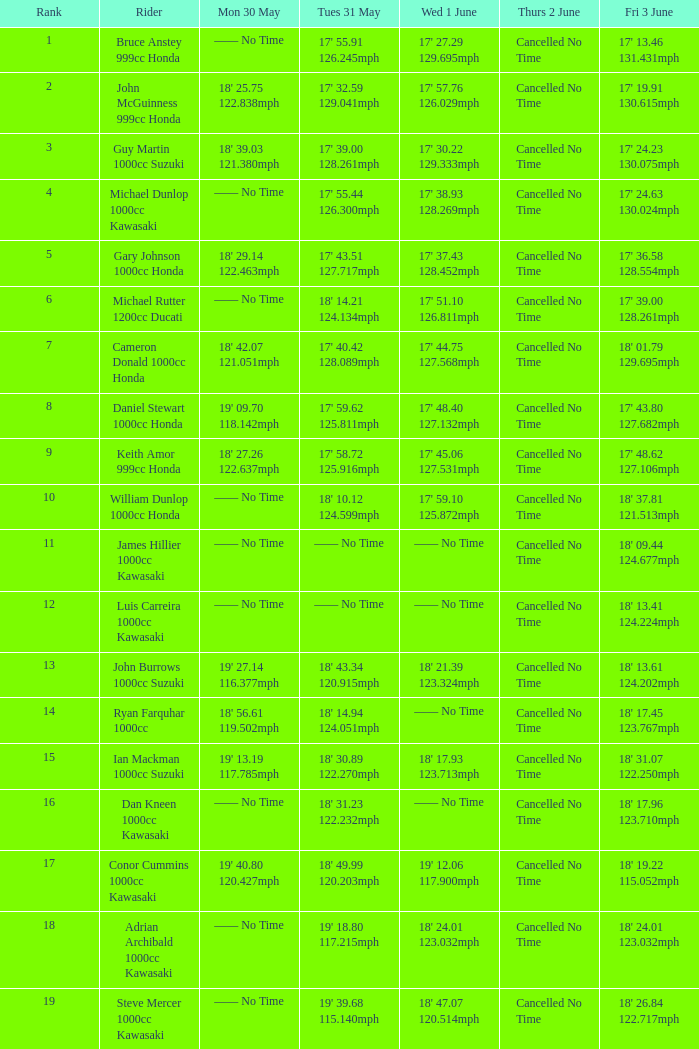Help me parse the entirety of this table. {'header': ['Rank', 'Rider', 'Mon 30 May', 'Tues 31 May', 'Wed 1 June', 'Thurs 2 June', 'Fri 3 June'], 'rows': [['1', 'Bruce Anstey 999cc Honda', '—— No Time', "17' 55.91 126.245mph", "17' 27.29 129.695mph", 'Cancelled No Time', "17' 13.46 131.431mph"], ['2', 'John McGuinness 999cc Honda', "18' 25.75 122.838mph", "17' 32.59 129.041mph", "17' 57.76 126.029mph", 'Cancelled No Time', "17' 19.91 130.615mph"], ['3', 'Guy Martin 1000cc Suzuki', "18' 39.03 121.380mph", "17' 39.00 128.261mph", "17' 30.22 129.333mph", 'Cancelled No Time', "17' 24.23 130.075mph"], ['4', 'Michael Dunlop 1000cc Kawasaki', '—— No Time', "17' 55.44 126.300mph", "17' 38.93 128.269mph", 'Cancelled No Time', "17' 24.63 130.024mph"], ['5', 'Gary Johnson 1000cc Honda', "18' 29.14 122.463mph", "17' 43.51 127.717mph", "17' 37.43 128.452mph", 'Cancelled No Time', "17' 36.58 128.554mph"], ['6', 'Michael Rutter 1200cc Ducati', '—— No Time', "18' 14.21 124.134mph", "17' 51.10 126.811mph", 'Cancelled No Time', "17' 39.00 128.261mph"], ['7', 'Cameron Donald 1000cc Honda', "18' 42.07 121.051mph", "17' 40.42 128.089mph", "17' 44.75 127.568mph", 'Cancelled No Time', "18' 01.79 129.695mph"], ['8', 'Daniel Stewart 1000cc Honda', "19' 09.70 118.142mph", "17' 59.62 125.811mph", "17' 48.40 127.132mph", 'Cancelled No Time', "17' 43.80 127.682mph"], ['9', 'Keith Amor 999cc Honda', "18' 27.26 122.637mph", "17' 58.72 125.916mph", "17' 45.06 127.531mph", 'Cancelled No Time', "17' 48.62 127.106mph"], ['10', 'William Dunlop 1000cc Honda', '—— No Time', "18' 10.12 124.599mph", "17' 59.10 125.872mph", 'Cancelled No Time', "18' 37.81 121.513mph"], ['11', 'James Hillier 1000cc Kawasaki', '—— No Time', '—— No Time', '—— No Time', 'Cancelled No Time', "18' 09.44 124.677mph"], ['12', 'Luis Carreira 1000cc Kawasaki', '—— No Time', '—— No Time', '—— No Time', 'Cancelled No Time', "18' 13.41 124.224mph"], ['13', 'John Burrows 1000cc Suzuki', "19' 27.14 116.377mph", "18' 43.34 120.915mph", "18' 21.39 123.324mph", 'Cancelled No Time', "18' 13.61 124.202mph"], ['14', 'Ryan Farquhar 1000cc', "18' 56.61 119.502mph", "18' 14.94 124.051mph", '—— No Time', 'Cancelled No Time', "18' 17.45 123.767mph"], ['15', 'Ian Mackman 1000cc Suzuki', "19' 13.19 117.785mph", "18' 30.89 122.270mph", "18' 17.93 123.713mph", 'Cancelled No Time', "18' 31.07 122.250mph"], ['16', 'Dan Kneen 1000cc Kawasaki', '—— No Time', "18' 31.23 122.232mph", '—— No Time', 'Cancelled No Time', "18' 17.96 123.710mph"], ['17', 'Conor Cummins 1000cc Kawasaki', "19' 40.80 120.427mph", "18' 49.99 120.203mph", "19' 12.06 117.900mph", 'Cancelled No Time', "18' 19.22 115.052mph"], ['18', 'Adrian Archibald 1000cc Kawasaki', '—— No Time', "19' 18.80 117.215mph", "18' 24.01 123.032mph", 'Cancelled No Time', "18' 24.01 123.032mph"], ['19', 'Steve Mercer 1000cc Kawasaki', '—— No Time', "19' 39.68 115.140mph", "18' 47.07 120.514mph", 'Cancelled No Time', "18' 26.84 122.717mph"]]} What is the Thurs 2 June time for the rider with a Fri 3 June time of 17' 36.58 128.554mph? Cancelled No Time. 